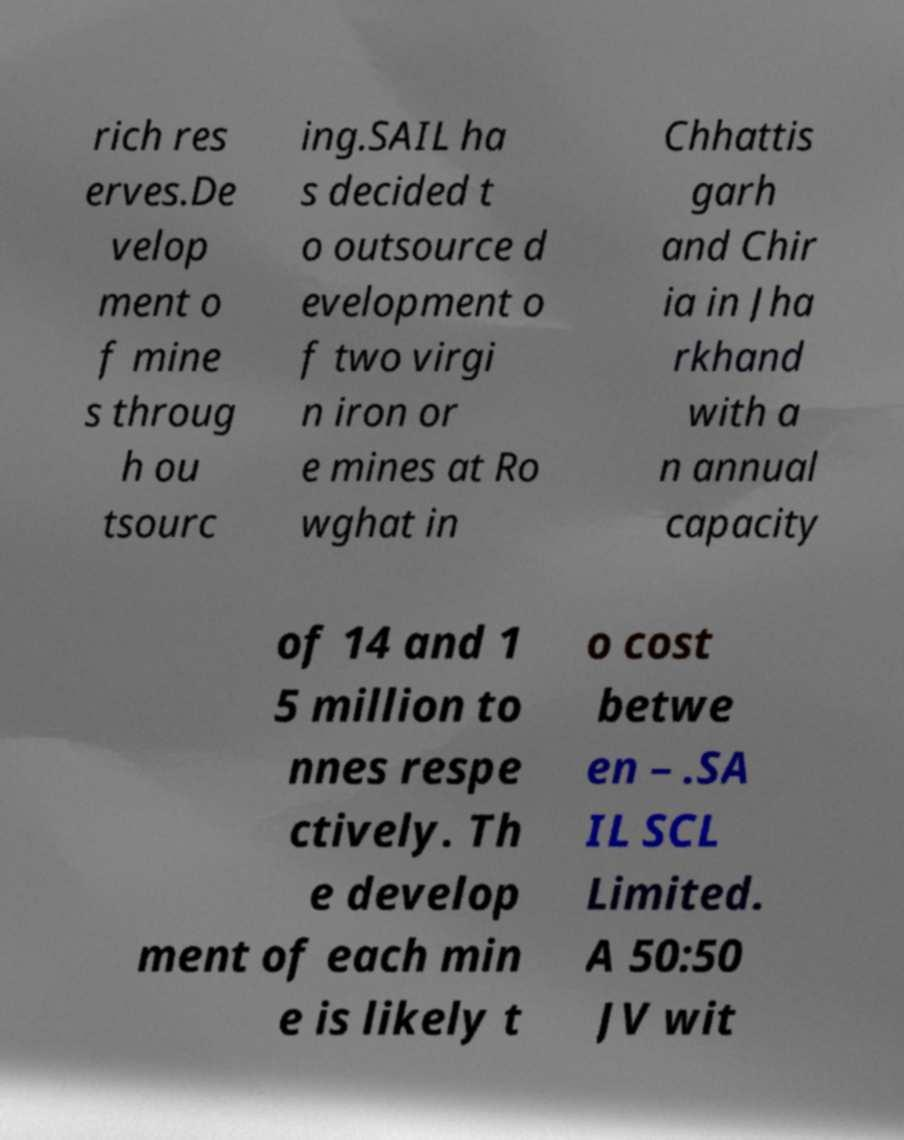There's text embedded in this image that I need extracted. Can you transcribe it verbatim? rich res erves.De velop ment o f mine s throug h ou tsourc ing.SAIL ha s decided t o outsource d evelopment o f two virgi n iron or e mines at Ro wghat in Chhattis garh and Chir ia in Jha rkhand with a n annual capacity of 14 and 1 5 million to nnes respe ctively. Th e develop ment of each min e is likely t o cost betwe en – .SA IL SCL Limited. A 50:50 JV wit 